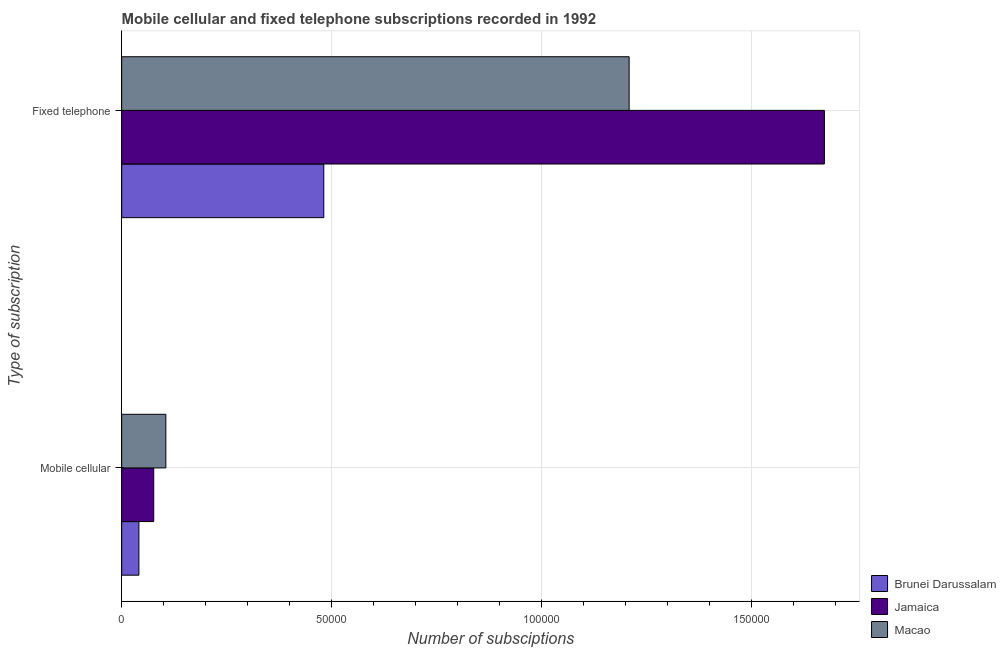How many groups of bars are there?
Your response must be concise. 2. Are the number of bars on each tick of the Y-axis equal?
Your answer should be compact. Yes. How many bars are there on the 1st tick from the top?
Your response must be concise. 3. What is the label of the 2nd group of bars from the top?
Your response must be concise. Mobile cellular. What is the number of fixed telephone subscriptions in Macao?
Provide a short and direct response. 1.21e+05. Across all countries, what is the maximum number of mobile cellular subscriptions?
Provide a short and direct response. 1.05e+04. Across all countries, what is the minimum number of fixed telephone subscriptions?
Give a very brief answer. 4.81e+04. In which country was the number of mobile cellular subscriptions maximum?
Your answer should be compact. Macao. In which country was the number of mobile cellular subscriptions minimum?
Your answer should be very brief. Brunei Darussalam. What is the total number of fixed telephone subscriptions in the graph?
Provide a succinct answer. 3.36e+05. What is the difference between the number of fixed telephone subscriptions in Jamaica and that in Brunei Darussalam?
Ensure brevity in your answer.  1.19e+05. What is the difference between the number of mobile cellular subscriptions in Brunei Darussalam and the number of fixed telephone subscriptions in Macao?
Give a very brief answer. -1.17e+05. What is the average number of fixed telephone subscriptions per country?
Make the answer very short. 1.12e+05. What is the difference between the number of fixed telephone subscriptions and number of mobile cellular subscriptions in Brunei Darussalam?
Offer a very short reply. 4.40e+04. What is the ratio of the number of mobile cellular subscriptions in Macao to that in Jamaica?
Offer a terse response. 1.38. In how many countries, is the number of fixed telephone subscriptions greater than the average number of fixed telephone subscriptions taken over all countries?
Your answer should be very brief. 2. What does the 1st bar from the top in Fixed telephone represents?
Provide a short and direct response. Macao. What does the 2nd bar from the bottom in Mobile cellular represents?
Offer a very short reply. Jamaica. How many bars are there?
Offer a very short reply. 6. How many countries are there in the graph?
Provide a short and direct response. 3. Are the values on the major ticks of X-axis written in scientific E-notation?
Offer a terse response. No. Does the graph contain any zero values?
Give a very brief answer. No. How are the legend labels stacked?
Offer a terse response. Vertical. What is the title of the graph?
Offer a terse response. Mobile cellular and fixed telephone subscriptions recorded in 1992. What is the label or title of the X-axis?
Provide a short and direct response. Number of subsciptions. What is the label or title of the Y-axis?
Offer a terse response. Type of subscription. What is the Number of subsciptions of Brunei Darussalam in Mobile cellular?
Offer a very short reply. 4103. What is the Number of subsciptions in Jamaica in Mobile cellular?
Provide a short and direct response. 7628. What is the Number of subsciptions in Macao in Mobile cellular?
Offer a terse response. 1.05e+04. What is the Number of subsciptions of Brunei Darussalam in Fixed telephone?
Offer a very short reply. 4.81e+04. What is the Number of subsciptions of Jamaica in Fixed telephone?
Provide a succinct answer. 1.67e+05. What is the Number of subsciptions of Macao in Fixed telephone?
Offer a very short reply. 1.21e+05. Across all Type of subscription, what is the maximum Number of subsciptions in Brunei Darussalam?
Make the answer very short. 4.81e+04. Across all Type of subscription, what is the maximum Number of subsciptions in Jamaica?
Ensure brevity in your answer.  1.67e+05. Across all Type of subscription, what is the maximum Number of subsciptions of Macao?
Provide a short and direct response. 1.21e+05. Across all Type of subscription, what is the minimum Number of subsciptions of Brunei Darussalam?
Offer a terse response. 4103. Across all Type of subscription, what is the minimum Number of subsciptions in Jamaica?
Provide a succinct answer. 7628. Across all Type of subscription, what is the minimum Number of subsciptions in Macao?
Your answer should be very brief. 1.05e+04. What is the total Number of subsciptions in Brunei Darussalam in the graph?
Give a very brief answer. 5.22e+04. What is the total Number of subsciptions of Jamaica in the graph?
Offer a terse response. 1.75e+05. What is the total Number of subsciptions in Macao in the graph?
Your response must be concise. 1.31e+05. What is the difference between the Number of subsciptions in Brunei Darussalam in Mobile cellular and that in Fixed telephone?
Provide a short and direct response. -4.40e+04. What is the difference between the Number of subsciptions of Jamaica in Mobile cellular and that in Fixed telephone?
Offer a very short reply. -1.60e+05. What is the difference between the Number of subsciptions in Macao in Mobile cellular and that in Fixed telephone?
Keep it short and to the point. -1.10e+05. What is the difference between the Number of subsciptions in Brunei Darussalam in Mobile cellular and the Number of subsciptions in Jamaica in Fixed telephone?
Keep it short and to the point. -1.63e+05. What is the difference between the Number of subsciptions in Brunei Darussalam in Mobile cellular and the Number of subsciptions in Macao in Fixed telephone?
Your answer should be very brief. -1.17e+05. What is the difference between the Number of subsciptions of Jamaica in Mobile cellular and the Number of subsciptions of Macao in Fixed telephone?
Ensure brevity in your answer.  -1.13e+05. What is the average Number of subsciptions of Brunei Darussalam per Type of subscription?
Your answer should be compact. 2.61e+04. What is the average Number of subsciptions in Jamaica per Type of subscription?
Your answer should be very brief. 8.74e+04. What is the average Number of subsciptions of Macao per Type of subscription?
Keep it short and to the point. 6.56e+04. What is the difference between the Number of subsciptions in Brunei Darussalam and Number of subsciptions in Jamaica in Mobile cellular?
Ensure brevity in your answer.  -3525. What is the difference between the Number of subsciptions in Brunei Darussalam and Number of subsciptions in Macao in Mobile cellular?
Make the answer very short. -6410. What is the difference between the Number of subsciptions of Jamaica and Number of subsciptions of Macao in Mobile cellular?
Offer a very short reply. -2885. What is the difference between the Number of subsciptions in Brunei Darussalam and Number of subsciptions in Jamaica in Fixed telephone?
Make the answer very short. -1.19e+05. What is the difference between the Number of subsciptions of Brunei Darussalam and Number of subsciptions of Macao in Fixed telephone?
Provide a succinct answer. -7.27e+04. What is the difference between the Number of subsciptions of Jamaica and Number of subsciptions of Macao in Fixed telephone?
Your answer should be compact. 4.65e+04. What is the ratio of the Number of subsciptions of Brunei Darussalam in Mobile cellular to that in Fixed telephone?
Offer a terse response. 0.09. What is the ratio of the Number of subsciptions in Jamaica in Mobile cellular to that in Fixed telephone?
Make the answer very short. 0.05. What is the ratio of the Number of subsciptions of Macao in Mobile cellular to that in Fixed telephone?
Give a very brief answer. 0.09. What is the difference between the highest and the second highest Number of subsciptions in Brunei Darussalam?
Your response must be concise. 4.40e+04. What is the difference between the highest and the second highest Number of subsciptions in Jamaica?
Provide a short and direct response. 1.60e+05. What is the difference between the highest and the second highest Number of subsciptions of Macao?
Offer a very short reply. 1.10e+05. What is the difference between the highest and the lowest Number of subsciptions of Brunei Darussalam?
Your answer should be compact. 4.40e+04. What is the difference between the highest and the lowest Number of subsciptions in Jamaica?
Ensure brevity in your answer.  1.60e+05. What is the difference between the highest and the lowest Number of subsciptions in Macao?
Your answer should be compact. 1.10e+05. 